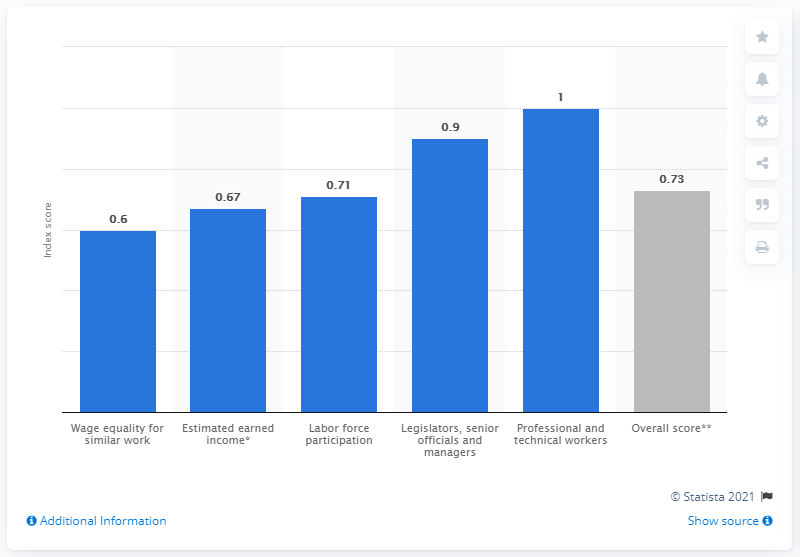Identify some key points in this picture. In 2021, Panama's gender gap index score was 0.73, indicating progress towards gender equality but still a significant gap remaining. According to estimates, Panama's earned income in 2021 was approximately 0.67. 